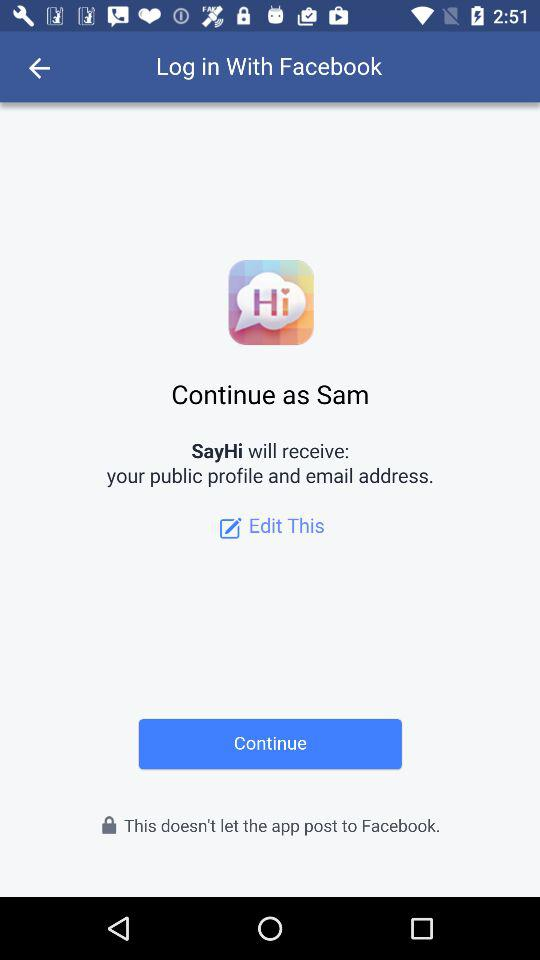What application will receive the public profile and email address? The application that will receive the public profile and email address is "SayHi". 